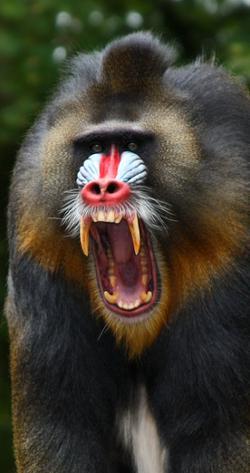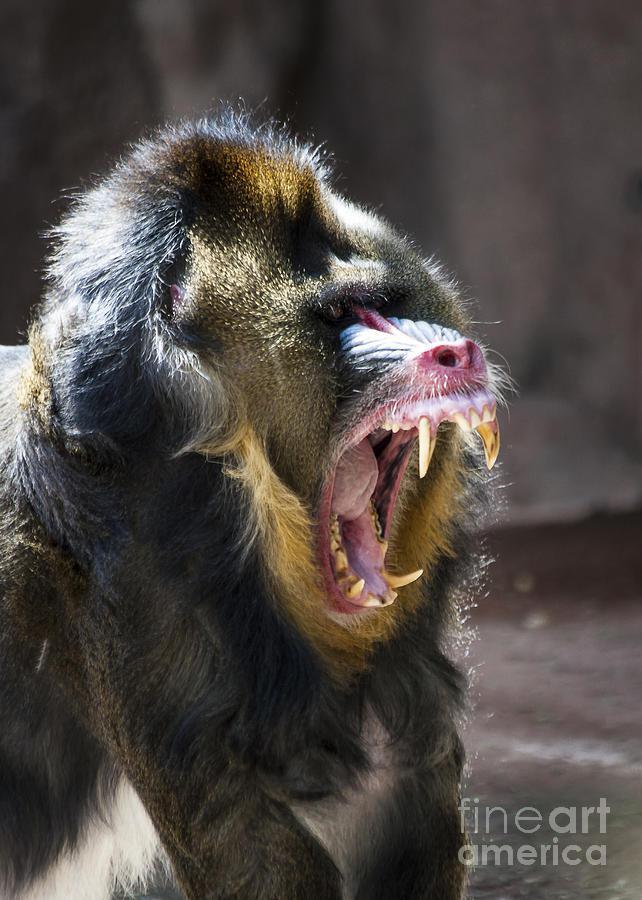The first image is the image on the left, the second image is the image on the right. Examine the images to the left and right. Is the description "The image on the left contains exactly one animal, and the image on the right is the exact same species and gender as the image on the left." accurate? Answer yes or no. Yes. 